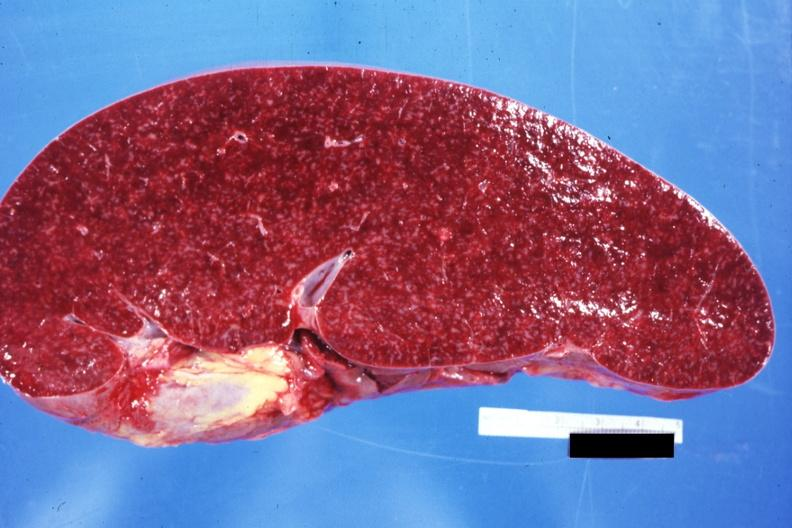how does cut surface prominent lymph follicles size appear normal see sides this case?
Answer the question using a single word or phrase. Other 